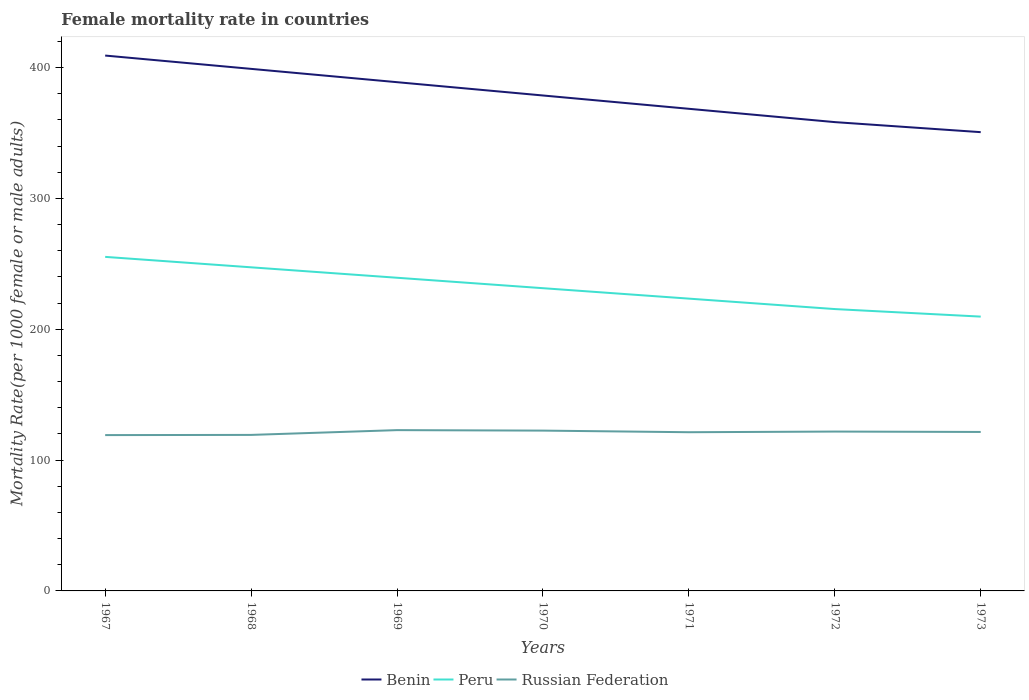How many different coloured lines are there?
Give a very brief answer. 3. Does the line corresponding to Russian Federation intersect with the line corresponding to Benin?
Your answer should be very brief. No. Is the number of lines equal to the number of legend labels?
Offer a terse response. Yes. Across all years, what is the maximum female mortality rate in Peru?
Provide a short and direct response. 209.66. In which year was the female mortality rate in Russian Federation maximum?
Your answer should be compact. 1967. What is the total female mortality rate in Peru in the graph?
Give a very brief answer. 21.72. What is the difference between the highest and the second highest female mortality rate in Benin?
Your response must be concise. 58.55. Is the female mortality rate in Peru strictly greater than the female mortality rate in Russian Federation over the years?
Keep it short and to the point. No. How many lines are there?
Provide a succinct answer. 3. What is the difference between two consecutive major ticks on the Y-axis?
Give a very brief answer. 100. Are the values on the major ticks of Y-axis written in scientific E-notation?
Keep it short and to the point. No. Does the graph contain grids?
Give a very brief answer. No. Where does the legend appear in the graph?
Offer a very short reply. Bottom center. How are the legend labels stacked?
Offer a very short reply. Horizontal. What is the title of the graph?
Offer a terse response. Female mortality rate in countries. Does "Guam" appear as one of the legend labels in the graph?
Your answer should be compact. No. What is the label or title of the X-axis?
Provide a succinct answer. Years. What is the label or title of the Y-axis?
Offer a terse response. Mortality Rate(per 1000 female or male adults). What is the Mortality Rate(per 1000 female or male adults) in Benin in 1967?
Your answer should be compact. 409.19. What is the Mortality Rate(per 1000 female or male adults) of Peru in 1967?
Keep it short and to the point. 255.31. What is the Mortality Rate(per 1000 female or male adults) in Russian Federation in 1967?
Make the answer very short. 119.1. What is the Mortality Rate(per 1000 female or male adults) of Benin in 1968?
Provide a succinct answer. 399.01. What is the Mortality Rate(per 1000 female or male adults) of Peru in 1968?
Provide a succinct answer. 247.34. What is the Mortality Rate(per 1000 female or male adults) of Russian Federation in 1968?
Ensure brevity in your answer.  119.24. What is the Mortality Rate(per 1000 female or male adults) in Benin in 1969?
Your answer should be compact. 388.84. What is the Mortality Rate(per 1000 female or male adults) of Peru in 1969?
Ensure brevity in your answer.  239.36. What is the Mortality Rate(per 1000 female or male adults) of Russian Federation in 1969?
Your answer should be very brief. 122.9. What is the Mortality Rate(per 1000 female or male adults) in Benin in 1970?
Make the answer very short. 378.66. What is the Mortality Rate(per 1000 female or male adults) in Peru in 1970?
Provide a short and direct response. 231.38. What is the Mortality Rate(per 1000 female or male adults) in Russian Federation in 1970?
Your answer should be very brief. 122.53. What is the Mortality Rate(per 1000 female or male adults) in Benin in 1971?
Your response must be concise. 368.49. What is the Mortality Rate(per 1000 female or male adults) in Peru in 1971?
Offer a very short reply. 223.4. What is the Mortality Rate(per 1000 female or male adults) in Russian Federation in 1971?
Provide a succinct answer. 121.3. What is the Mortality Rate(per 1000 female or male adults) of Benin in 1972?
Ensure brevity in your answer.  358.31. What is the Mortality Rate(per 1000 female or male adults) in Peru in 1972?
Provide a succinct answer. 215.43. What is the Mortality Rate(per 1000 female or male adults) in Russian Federation in 1972?
Your answer should be very brief. 121.8. What is the Mortality Rate(per 1000 female or male adults) in Benin in 1973?
Give a very brief answer. 350.64. What is the Mortality Rate(per 1000 female or male adults) of Peru in 1973?
Give a very brief answer. 209.66. What is the Mortality Rate(per 1000 female or male adults) in Russian Federation in 1973?
Ensure brevity in your answer.  121.5. Across all years, what is the maximum Mortality Rate(per 1000 female or male adults) in Benin?
Your answer should be compact. 409.19. Across all years, what is the maximum Mortality Rate(per 1000 female or male adults) in Peru?
Provide a short and direct response. 255.31. Across all years, what is the maximum Mortality Rate(per 1000 female or male adults) in Russian Federation?
Ensure brevity in your answer.  122.9. Across all years, what is the minimum Mortality Rate(per 1000 female or male adults) of Benin?
Keep it short and to the point. 350.64. Across all years, what is the minimum Mortality Rate(per 1000 female or male adults) of Peru?
Give a very brief answer. 209.66. Across all years, what is the minimum Mortality Rate(per 1000 female or male adults) of Russian Federation?
Give a very brief answer. 119.1. What is the total Mortality Rate(per 1000 female or male adults) of Benin in the graph?
Offer a terse response. 2653.14. What is the total Mortality Rate(per 1000 female or male adults) of Peru in the graph?
Give a very brief answer. 1621.88. What is the total Mortality Rate(per 1000 female or male adults) of Russian Federation in the graph?
Give a very brief answer. 848.36. What is the difference between the Mortality Rate(per 1000 female or male adults) of Benin in 1967 and that in 1968?
Give a very brief answer. 10.17. What is the difference between the Mortality Rate(per 1000 female or male adults) in Peru in 1967 and that in 1968?
Your answer should be compact. 7.98. What is the difference between the Mortality Rate(per 1000 female or male adults) in Russian Federation in 1967 and that in 1968?
Give a very brief answer. -0.15. What is the difference between the Mortality Rate(per 1000 female or male adults) in Benin in 1967 and that in 1969?
Provide a short and direct response. 20.35. What is the difference between the Mortality Rate(per 1000 female or male adults) of Peru in 1967 and that in 1969?
Give a very brief answer. 15.96. What is the difference between the Mortality Rate(per 1000 female or male adults) of Russian Federation in 1967 and that in 1969?
Provide a short and direct response. -3.81. What is the difference between the Mortality Rate(per 1000 female or male adults) of Benin in 1967 and that in 1970?
Your answer should be very brief. 30.52. What is the difference between the Mortality Rate(per 1000 female or male adults) in Peru in 1967 and that in 1970?
Keep it short and to the point. 23.93. What is the difference between the Mortality Rate(per 1000 female or male adults) of Russian Federation in 1967 and that in 1970?
Your answer should be compact. -3.43. What is the difference between the Mortality Rate(per 1000 female or male adults) in Benin in 1967 and that in 1971?
Provide a short and direct response. 40.7. What is the difference between the Mortality Rate(per 1000 female or male adults) of Peru in 1967 and that in 1971?
Your answer should be compact. 31.91. What is the difference between the Mortality Rate(per 1000 female or male adults) of Russian Federation in 1967 and that in 1971?
Give a very brief answer. -2.2. What is the difference between the Mortality Rate(per 1000 female or male adults) of Benin in 1967 and that in 1972?
Provide a short and direct response. 50.87. What is the difference between the Mortality Rate(per 1000 female or male adults) in Peru in 1967 and that in 1972?
Offer a terse response. 39.89. What is the difference between the Mortality Rate(per 1000 female or male adults) in Russian Federation in 1967 and that in 1972?
Your response must be concise. -2.7. What is the difference between the Mortality Rate(per 1000 female or male adults) of Benin in 1967 and that in 1973?
Make the answer very short. 58.55. What is the difference between the Mortality Rate(per 1000 female or male adults) of Peru in 1967 and that in 1973?
Make the answer very short. 45.66. What is the difference between the Mortality Rate(per 1000 female or male adults) of Russian Federation in 1967 and that in 1973?
Ensure brevity in your answer.  -2.4. What is the difference between the Mortality Rate(per 1000 female or male adults) in Benin in 1968 and that in 1969?
Your answer should be very brief. 10.18. What is the difference between the Mortality Rate(per 1000 female or male adults) in Peru in 1968 and that in 1969?
Make the answer very short. 7.98. What is the difference between the Mortality Rate(per 1000 female or male adults) in Russian Federation in 1968 and that in 1969?
Offer a very short reply. -3.66. What is the difference between the Mortality Rate(per 1000 female or male adults) in Benin in 1968 and that in 1970?
Your response must be concise. 20.35. What is the difference between the Mortality Rate(per 1000 female or male adults) in Peru in 1968 and that in 1970?
Give a very brief answer. 15.96. What is the difference between the Mortality Rate(per 1000 female or male adults) in Russian Federation in 1968 and that in 1970?
Give a very brief answer. -3.29. What is the difference between the Mortality Rate(per 1000 female or male adults) of Benin in 1968 and that in 1971?
Offer a terse response. 30.52. What is the difference between the Mortality Rate(per 1000 female or male adults) of Peru in 1968 and that in 1971?
Offer a terse response. 23.93. What is the difference between the Mortality Rate(per 1000 female or male adults) of Russian Federation in 1968 and that in 1971?
Your answer should be compact. -2.06. What is the difference between the Mortality Rate(per 1000 female or male adults) in Benin in 1968 and that in 1972?
Provide a succinct answer. 40.7. What is the difference between the Mortality Rate(per 1000 female or male adults) in Peru in 1968 and that in 1972?
Offer a terse response. 31.91. What is the difference between the Mortality Rate(per 1000 female or male adults) in Russian Federation in 1968 and that in 1972?
Your answer should be compact. -2.55. What is the difference between the Mortality Rate(per 1000 female or male adults) of Benin in 1968 and that in 1973?
Make the answer very short. 48.38. What is the difference between the Mortality Rate(per 1000 female or male adults) of Peru in 1968 and that in 1973?
Make the answer very short. 37.68. What is the difference between the Mortality Rate(per 1000 female or male adults) of Russian Federation in 1968 and that in 1973?
Your answer should be very brief. -2.25. What is the difference between the Mortality Rate(per 1000 female or male adults) in Benin in 1969 and that in 1970?
Your answer should be very brief. 10.17. What is the difference between the Mortality Rate(per 1000 female or male adults) in Peru in 1969 and that in 1970?
Your answer should be very brief. 7.98. What is the difference between the Mortality Rate(per 1000 female or male adults) in Russian Federation in 1969 and that in 1970?
Your response must be concise. 0.37. What is the difference between the Mortality Rate(per 1000 female or male adults) in Benin in 1969 and that in 1971?
Your response must be concise. 20.35. What is the difference between the Mortality Rate(per 1000 female or male adults) of Peru in 1969 and that in 1971?
Your answer should be compact. 15.96. What is the difference between the Mortality Rate(per 1000 female or male adults) of Russian Federation in 1969 and that in 1971?
Your answer should be very brief. 1.6. What is the difference between the Mortality Rate(per 1000 female or male adults) of Benin in 1969 and that in 1972?
Your response must be concise. 30.52. What is the difference between the Mortality Rate(per 1000 female or male adults) in Peru in 1969 and that in 1972?
Ensure brevity in your answer.  23.93. What is the difference between the Mortality Rate(per 1000 female or male adults) in Russian Federation in 1969 and that in 1972?
Give a very brief answer. 1.1. What is the difference between the Mortality Rate(per 1000 female or male adults) in Benin in 1969 and that in 1973?
Ensure brevity in your answer.  38.2. What is the difference between the Mortality Rate(per 1000 female or male adults) in Peru in 1969 and that in 1973?
Make the answer very short. 29.7. What is the difference between the Mortality Rate(per 1000 female or male adults) of Russian Federation in 1969 and that in 1973?
Provide a succinct answer. 1.41. What is the difference between the Mortality Rate(per 1000 female or male adults) in Benin in 1970 and that in 1971?
Provide a succinct answer. 10.17. What is the difference between the Mortality Rate(per 1000 female or male adults) of Peru in 1970 and that in 1971?
Your response must be concise. 7.98. What is the difference between the Mortality Rate(per 1000 female or male adults) in Russian Federation in 1970 and that in 1971?
Provide a short and direct response. 1.23. What is the difference between the Mortality Rate(per 1000 female or male adults) of Benin in 1970 and that in 1972?
Offer a terse response. 20.35. What is the difference between the Mortality Rate(per 1000 female or male adults) in Peru in 1970 and that in 1972?
Ensure brevity in your answer.  15.96. What is the difference between the Mortality Rate(per 1000 female or male adults) of Russian Federation in 1970 and that in 1972?
Your response must be concise. 0.73. What is the difference between the Mortality Rate(per 1000 female or male adults) in Benin in 1970 and that in 1973?
Provide a succinct answer. 28.03. What is the difference between the Mortality Rate(per 1000 female or male adults) in Peru in 1970 and that in 1973?
Make the answer very short. 21.72. What is the difference between the Mortality Rate(per 1000 female or male adults) in Russian Federation in 1970 and that in 1973?
Provide a short and direct response. 1.03. What is the difference between the Mortality Rate(per 1000 female or male adults) of Benin in 1971 and that in 1972?
Offer a very short reply. 10.18. What is the difference between the Mortality Rate(per 1000 female or male adults) of Peru in 1971 and that in 1972?
Your answer should be compact. 7.98. What is the difference between the Mortality Rate(per 1000 female or male adults) of Russian Federation in 1971 and that in 1972?
Make the answer very short. -0.5. What is the difference between the Mortality Rate(per 1000 female or male adults) in Benin in 1971 and that in 1973?
Offer a very short reply. 17.85. What is the difference between the Mortality Rate(per 1000 female or male adults) in Peru in 1971 and that in 1973?
Offer a terse response. 13.74. What is the difference between the Mortality Rate(per 1000 female or male adults) in Russian Federation in 1971 and that in 1973?
Offer a terse response. -0.19. What is the difference between the Mortality Rate(per 1000 female or male adults) of Benin in 1972 and that in 1973?
Give a very brief answer. 7.68. What is the difference between the Mortality Rate(per 1000 female or male adults) in Peru in 1972 and that in 1973?
Offer a terse response. 5.77. What is the difference between the Mortality Rate(per 1000 female or male adults) of Russian Federation in 1972 and that in 1973?
Your answer should be very brief. 0.3. What is the difference between the Mortality Rate(per 1000 female or male adults) of Benin in 1967 and the Mortality Rate(per 1000 female or male adults) of Peru in 1968?
Ensure brevity in your answer.  161.85. What is the difference between the Mortality Rate(per 1000 female or male adults) of Benin in 1967 and the Mortality Rate(per 1000 female or male adults) of Russian Federation in 1968?
Ensure brevity in your answer.  289.94. What is the difference between the Mortality Rate(per 1000 female or male adults) in Peru in 1967 and the Mortality Rate(per 1000 female or male adults) in Russian Federation in 1968?
Ensure brevity in your answer.  136.07. What is the difference between the Mortality Rate(per 1000 female or male adults) of Benin in 1967 and the Mortality Rate(per 1000 female or male adults) of Peru in 1969?
Offer a terse response. 169.83. What is the difference between the Mortality Rate(per 1000 female or male adults) of Benin in 1967 and the Mortality Rate(per 1000 female or male adults) of Russian Federation in 1969?
Your answer should be very brief. 286.29. What is the difference between the Mortality Rate(per 1000 female or male adults) of Peru in 1967 and the Mortality Rate(per 1000 female or male adults) of Russian Federation in 1969?
Your answer should be compact. 132.41. What is the difference between the Mortality Rate(per 1000 female or male adults) of Benin in 1967 and the Mortality Rate(per 1000 female or male adults) of Peru in 1970?
Your answer should be very brief. 177.81. What is the difference between the Mortality Rate(per 1000 female or male adults) of Benin in 1967 and the Mortality Rate(per 1000 female or male adults) of Russian Federation in 1970?
Provide a short and direct response. 286.66. What is the difference between the Mortality Rate(per 1000 female or male adults) of Peru in 1967 and the Mortality Rate(per 1000 female or male adults) of Russian Federation in 1970?
Your response must be concise. 132.78. What is the difference between the Mortality Rate(per 1000 female or male adults) of Benin in 1967 and the Mortality Rate(per 1000 female or male adults) of Peru in 1971?
Offer a very short reply. 185.78. What is the difference between the Mortality Rate(per 1000 female or male adults) of Benin in 1967 and the Mortality Rate(per 1000 female or male adults) of Russian Federation in 1971?
Your response must be concise. 287.89. What is the difference between the Mortality Rate(per 1000 female or male adults) of Peru in 1967 and the Mortality Rate(per 1000 female or male adults) of Russian Federation in 1971?
Your response must be concise. 134.01. What is the difference between the Mortality Rate(per 1000 female or male adults) in Benin in 1967 and the Mortality Rate(per 1000 female or male adults) in Peru in 1972?
Make the answer very short. 193.76. What is the difference between the Mortality Rate(per 1000 female or male adults) of Benin in 1967 and the Mortality Rate(per 1000 female or male adults) of Russian Federation in 1972?
Your answer should be very brief. 287.39. What is the difference between the Mortality Rate(per 1000 female or male adults) of Peru in 1967 and the Mortality Rate(per 1000 female or male adults) of Russian Federation in 1972?
Offer a terse response. 133.52. What is the difference between the Mortality Rate(per 1000 female or male adults) of Benin in 1967 and the Mortality Rate(per 1000 female or male adults) of Peru in 1973?
Ensure brevity in your answer.  199.53. What is the difference between the Mortality Rate(per 1000 female or male adults) in Benin in 1967 and the Mortality Rate(per 1000 female or male adults) in Russian Federation in 1973?
Your response must be concise. 287.69. What is the difference between the Mortality Rate(per 1000 female or male adults) in Peru in 1967 and the Mortality Rate(per 1000 female or male adults) in Russian Federation in 1973?
Offer a terse response. 133.82. What is the difference between the Mortality Rate(per 1000 female or male adults) of Benin in 1968 and the Mortality Rate(per 1000 female or male adults) of Peru in 1969?
Provide a short and direct response. 159.65. What is the difference between the Mortality Rate(per 1000 female or male adults) in Benin in 1968 and the Mortality Rate(per 1000 female or male adults) in Russian Federation in 1969?
Provide a succinct answer. 276.11. What is the difference between the Mortality Rate(per 1000 female or male adults) in Peru in 1968 and the Mortality Rate(per 1000 female or male adults) in Russian Federation in 1969?
Keep it short and to the point. 124.44. What is the difference between the Mortality Rate(per 1000 female or male adults) in Benin in 1968 and the Mortality Rate(per 1000 female or male adults) in Peru in 1970?
Ensure brevity in your answer.  167.63. What is the difference between the Mortality Rate(per 1000 female or male adults) of Benin in 1968 and the Mortality Rate(per 1000 female or male adults) of Russian Federation in 1970?
Provide a short and direct response. 276.48. What is the difference between the Mortality Rate(per 1000 female or male adults) in Peru in 1968 and the Mortality Rate(per 1000 female or male adults) in Russian Federation in 1970?
Give a very brief answer. 124.81. What is the difference between the Mortality Rate(per 1000 female or male adults) in Benin in 1968 and the Mortality Rate(per 1000 female or male adults) in Peru in 1971?
Your response must be concise. 175.61. What is the difference between the Mortality Rate(per 1000 female or male adults) of Benin in 1968 and the Mortality Rate(per 1000 female or male adults) of Russian Federation in 1971?
Offer a very short reply. 277.71. What is the difference between the Mortality Rate(per 1000 female or male adults) in Peru in 1968 and the Mortality Rate(per 1000 female or male adults) in Russian Federation in 1971?
Provide a succinct answer. 126.04. What is the difference between the Mortality Rate(per 1000 female or male adults) of Benin in 1968 and the Mortality Rate(per 1000 female or male adults) of Peru in 1972?
Provide a short and direct response. 183.59. What is the difference between the Mortality Rate(per 1000 female or male adults) of Benin in 1968 and the Mortality Rate(per 1000 female or male adults) of Russian Federation in 1972?
Provide a succinct answer. 277.22. What is the difference between the Mortality Rate(per 1000 female or male adults) in Peru in 1968 and the Mortality Rate(per 1000 female or male adults) in Russian Federation in 1972?
Give a very brief answer. 125.54. What is the difference between the Mortality Rate(per 1000 female or male adults) of Benin in 1968 and the Mortality Rate(per 1000 female or male adults) of Peru in 1973?
Your answer should be compact. 189.35. What is the difference between the Mortality Rate(per 1000 female or male adults) in Benin in 1968 and the Mortality Rate(per 1000 female or male adults) in Russian Federation in 1973?
Ensure brevity in your answer.  277.52. What is the difference between the Mortality Rate(per 1000 female or male adults) of Peru in 1968 and the Mortality Rate(per 1000 female or male adults) of Russian Federation in 1973?
Provide a succinct answer. 125.84. What is the difference between the Mortality Rate(per 1000 female or male adults) in Benin in 1969 and the Mortality Rate(per 1000 female or male adults) in Peru in 1970?
Offer a terse response. 157.46. What is the difference between the Mortality Rate(per 1000 female or male adults) in Benin in 1969 and the Mortality Rate(per 1000 female or male adults) in Russian Federation in 1970?
Provide a short and direct response. 266.31. What is the difference between the Mortality Rate(per 1000 female or male adults) in Peru in 1969 and the Mortality Rate(per 1000 female or male adults) in Russian Federation in 1970?
Provide a succinct answer. 116.83. What is the difference between the Mortality Rate(per 1000 female or male adults) of Benin in 1969 and the Mortality Rate(per 1000 female or male adults) of Peru in 1971?
Your answer should be very brief. 165.44. What is the difference between the Mortality Rate(per 1000 female or male adults) in Benin in 1969 and the Mortality Rate(per 1000 female or male adults) in Russian Federation in 1971?
Offer a very short reply. 267.54. What is the difference between the Mortality Rate(per 1000 female or male adults) in Peru in 1969 and the Mortality Rate(per 1000 female or male adults) in Russian Federation in 1971?
Your answer should be compact. 118.06. What is the difference between the Mortality Rate(per 1000 female or male adults) of Benin in 1969 and the Mortality Rate(per 1000 female or male adults) of Peru in 1972?
Give a very brief answer. 173.41. What is the difference between the Mortality Rate(per 1000 female or male adults) in Benin in 1969 and the Mortality Rate(per 1000 female or male adults) in Russian Federation in 1972?
Your answer should be compact. 267.04. What is the difference between the Mortality Rate(per 1000 female or male adults) in Peru in 1969 and the Mortality Rate(per 1000 female or male adults) in Russian Federation in 1972?
Offer a very short reply. 117.56. What is the difference between the Mortality Rate(per 1000 female or male adults) in Benin in 1969 and the Mortality Rate(per 1000 female or male adults) in Peru in 1973?
Make the answer very short. 179.18. What is the difference between the Mortality Rate(per 1000 female or male adults) in Benin in 1969 and the Mortality Rate(per 1000 female or male adults) in Russian Federation in 1973?
Offer a terse response. 267.34. What is the difference between the Mortality Rate(per 1000 female or male adults) of Peru in 1969 and the Mortality Rate(per 1000 female or male adults) of Russian Federation in 1973?
Your answer should be compact. 117.86. What is the difference between the Mortality Rate(per 1000 female or male adults) of Benin in 1970 and the Mortality Rate(per 1000 female or male adults) of Peru in 1971?
Offer a very short reply. 155.26. What is the difference between the Mortality Rate(per 1000 female or male adults) in Benin in 1970 and the Mortality Rate(per 1000 female or male adults) in Russian Federation in 1971?
Offer a terse response. 257.36. What is the difference between the Mortality Rate(per 1000 female or male adults) of Peru in 1970 and the Mortality Rate(per 1000 female or male adults) of Russian Federation in 1971?
Give a very brief answer. 110.08. What is the difference between the Mortality Rate(per 1000 female or male adults) of Benin in 1970 and the Mortality Rate(per 1000 female or male adults) of Peru in 1972?
Give a very brief answer. 163.24. What is the difference between the Mortality Rate(per 1000 female or male adults) in Benin in 1970 and the Mortality Rate(per 1000 female or male adults) in Russian Federation in 1972?
Your answer should be compact. 256.87. What is the difference between the Mortality Rate(per 1000 female or male adults) of Peru in 1970 and the Mortality Rate(per 1000 female or male adults) of Russian Federation in 1972?
Offer a terse response. 109.58. What is the difference between the Mortality Rate(per 1000 female or male adults) of Benin in 1970 and the Mortality Rate(per 1000 female or male adults) of Peru in 1973?
Keep it short and to the point. 169.01. What is the difference between the Mortality Rate(per 1000 female or male adults) in Benin in 1970 and the Mortality Rate(per 1000 female or male adults) in Russian Federation in 1973?
Keep it short and to the point. 257.17. What is the difference between the Mortality Rate(per 1000 female or male adults) in Peru in 1970 and the Mortality Rate(per 1000 female or male adults) in Russian Federation in 1973?
Your answer should be compact. 109.89. What is the difference between the Mortality Rate(per 1000 female or male adults) of Benin in 1971 and the Mortality Rate(per 1000 female or male adults) of Peru in 1972?
Make the answer very short. 153.06. What is the difference between the Mortality Rate(per 1000 female or male adults) in Benin in 1971 and the Mortality Rate(per 1000 female or male adults) in Russian Federation in 1972?
Your response must be concise. 246.69. What is the difference between the Mortality Rate(per 1000 female or male adults) in Peru in 1971 and the Mortality Rate(per 1000 female or male adults) in Russian Federation in 1972?
Offer a very short reply. 101.61. What is the difference between the Mortality Rate(per 1000 female or male adults) of Benin in 1971 and the Mortality Rate(per 1000 female or male adults) of Peru in 1973?
Make the answer very short. 158.83. What is the difference between the Mortality Rate(per 1000 female or male adults) of Benin in 1971 and the Mortality Rate(per 1000 female or male adults) of Russian Federation in 1973?
Keep it short and to the point. 247. What is the difference between the Mortality Rate(per 1000 female or male adults) in Peru in 1971 and the Mortality Rate(per 1000 female or male adults) in Russian Federation in 1973?
Offer a terse response. 101.91. What is the difference between the Mortality Rate(per 1000 female or male adults) of Benin in 1972 and the Mortality Rate(per 1000 female or male adults) of Peru in 1973?
Offer a very short reply. 148.66. What is the difference between the Mortality Rate(per 1000 female or male adults) in Benin in 1972 and the Mortality Rate(per 1000 female or male adults) in Russian Federation in 1973?
Offer a terse response. 236.82. What is the difference between the Mortality Rate(per 1000 female or male adults) of Peru in 1972 and the Mortality Rate(per 1000 female or male adults) of Russian Federation in 1973?
Provide a short and direct response. 93.93. What is the average Mortality Rate(per 1000 female or male adults) in Benin per year?
Offer a terse response. 379.02. What is the average Mortality Rate(per 1000 female or male adults) in Peru per year?
Your answer should be very brief. 231.7. What is the average Mortality Rate(per 1000 female or male adults) in Russian Federation per year?
Provide a succinct answer. 121.19. In the year 1967, what is the difference between the Mortality Rate(per 1000 female or male adults) of Benin and Mortality Rate(per 1000 female or male adults) of Peru?
Provide a short and direct response. 153.87. In the year 1967, what is the difference between the Mortality Rate(per 1000 female or male adults) in Benin and Mortality Rate(per 1000 female or male adults) in Russian Federation?
Provide a short and direct response. 290.09. In the year 1967, what is the difference between the Mortality Rate(per 1000 female or male adults) of Peru and Mortality Rate(per 1000 female or male adults) of Russian Federation?
Ensure brevity in your answer.  136.22. In the year 1968, what is the difference between the Mortality Rate(per 1000 female or male adults) in Benin and Mortality Rate(per 1000 female or male adults) in Peru?
Make the answer very short. 151.68. In the year 1968, what is the difference between the Mortality Rate(per 1000 female or male adults) of Benin and Mortality Rate(per 1000 female or male adults) of Russian Federation?
Give a very brief answer. 279.77. In the year 1968, what is the difference between the Mortality Rate(per 1000 female or male adults) of Peru and Mortality Rate(per 1000 female or male adults) of Russian Federation?
Make the answer very short. 128.09. In the year 1969, what is the difference between the Mortality Rate(per 1000 female or male adults) of Benin and Mortality Rate(per 1000 female or male adults) of Peru?
Provide a succinct answer. 149.48. In the year 1969, what is the difference between the Mortality Rate(per 1000 female or male adults) of Benin and Mortality Rate(per 1000 female or male adults) of Russian Federation?
Offer a very short reply. 265.94. In the year 1969, what is the difference between the Mortality Rate(per 1000 female or male adults) in Peru and Mortality Rate(per 1000 female or male adults) in Russian Federation?
Your response must be concise. 116.46. In the year 1970, what is the difference between the Mortality Rate(per 1000 female or male adults) in Benin and Mortality Rate(per 1000 female or male adults) in Peru?
Offer a terse response. 147.28. In the year 1970, what is the difference between the Mortality Rate(per 1000 female or male adults) in Benin and Mortality Rate(per 1000 female or male adults) in Russian Federation?
Offer a very short reply. 256.13. In the year 1970, what is the difference between the Mortality Rate(per 1000 female or male adults) in Peru and Mortality Rate(per 1000 female or male adults) in Russian Federation?
Give a very brief answer. 108.85. In the year 1971, what is the difference between the Mortality Rate(per 1000 female or male adults) in Benin and Mortality Rate(per 1000 female or male adults) in Peru?
Offer a very short reply. 145.09. In the year 1971, what is the difference between the Mortality Rate(per 1000 female or male adults) in Benin and Mortality Rate(per 1000 female or male adults) in Russian Federation?
Offer a very short reply. 247.19. In the year 1971, what is the difference between the Mortality Rate(per 1000 female or male adults) of Peru and Mortality Rate(per 1000 female or male adults) of Russian Federation?
Your answer should be compact. 102.1. In the year 1972, what is the difference between the Mortality Rate(per 1000 female or male adults) in Benin and Mortality Rate(per 1000 female or male adults) in Peru?
Offer a very short reply. 142.89. In the year 1972, what is the difference between the Mortality Rate(per 1000 female or male adults) in Benin and Mortality Rate(per 1000 female or male adults) in Russian Federation?
Provide a short and direct response. 236.52. In the year 1972, what is the difference between the Mortality Rate(per 1000 female or male adults) of Peru and Mortality Rate(per 1000 female or male adults) of Russian Federation?
Ensure brevity in your answer.  93.63. In the year 1973, what is the difference between the Mortality Rate(per 1000 female or male adults) of Benin and Mortality Rate(per 1000 female or male adults) of Peru?
Offer a very short reply. 140.98. In the year 1973, what is the difference between the Mortality Rate(per 1000 female or male adults) in Benin and Mortality Rate(per 1000 female or male adults) in Russian Federation?
Provide a short and direct response. 229.14. In the year 1973, what is the difference between the Mortality Rate(per 1000 female or male adults) in Peru and Mortality Rate(per 1000 female or male adults) in Russian Federation?
Give a very brief answer. 88.16. What is the ratio of the Mortality Rate(per 1000 female or male adults) in Benin in 1967 to that in 1968?
Your answer should be very brief. 1.03. What is the ratio of the Mortality Rate(per 1000 female or male adults) in Peru in 1967 to that in 1968?
Ensure brevity in your answer.  1.03. What is the ratio of the Mortality Rate(per 1000 female or male adults) of Benin in 1967 to that in 1969?
Provide a short and direct response. 1.05. What is the ratio of the Mortality Rate(per 1000 female or male adults) of Peru in 1967 to that in 1969?
Give a very brief answer. 1.07. What is the ratio of the Mortality Rate(per 1000 female or male adults) in Benin in 1967 to that in 1970?
Your answer should be very brief. 1.08. What is the ratio of the Mortality Rate(per 1000 female or male adults) in Peru in 1967 to that in 1970?
Your response must be concise. 1.1. What is the ratio of the Mortality Rate(per 1000 female or male adults) in Benin in 1967 to that in 1971?
Provide a succinct answer. 1.11. What is the ratio of the Mortality Rate(per 1000 female or male adults) of Peru in 1967 to that in 1971?
Your answer should be compact. 1.14. What is the ratio of the Mortality Rate(per 1000 female or male adults) of Russian Federation in 1967 to that in 1971?
Provide a short and direct response. 0.98. What is the ratio of the Mortality Rate(per 1000 female or male adults) of Benin in 1967 to that in 1972?
Your answer should be compact. 1.14. What is the ratio of the Mortality Rate(per 1000 female or male adults) of Peru in 1967 to that in 1972?
Give a very brief answer. 1.19. What is the ratio of the Mortality Rate(per 1000 female or male adults) in Russian Federation in 1967 to that in 1972?
Keep it short and to the point. 0.98. What is the ratio of the Mortality Rate(per 1000 female or male adults) of Benin in 1967 to that in 1973?
Provide a succinct answer. 1.17. What is the ratio of the Mortality Rate(per 1000 female or male adults) in Peru in 1967 to that in 1973?
Ensure brevity in your answer.  1.22. What is the ratio of the Mortality Rate(per 1000 female or male adults) in Russian Federation in 1967 to that in 1973?
Provide a short and direct response. 0.98. What is the ratio of the Mortality Rate(per 1000 female or male adults) in Benin in 1968 to that in 1969?
Give a very brief answer. 1.03. What is the ratio of the Mortality Rate(per 1000 female or male adults) in Peru in 1968 to that in 1969?
Offer a very short reply. 1.03. What is the ratio of the Mortality Rate(per 1000 female or male adults) in Russian Federation in 1968 to that in 1969?
Ensure brevity in your answer.  0.97. What is the ratio of the Mortality Rate(per 1000 female or male adults) of Benin in 1968 to that in 1970?
Ensure brevity in your answer.  1.05. What is the ratio of the Mortality Rate(per 1000 female or male adults) in Peru in 1968 to that in 1970?
Provide a short and direct response. 1.07. What is the ratio of the Mortality Rate(per 1000 female or male adults) of Russian Federation in 1968 to that in 1970?
Make the answer very short. 0.97. What is the ratio of the Mortality Rate(per 1000 female or male adults) in Benin in 1968 to that in 1971?
Offer a very short reply. 1.08. What is the ratio of the Mortality Rate(per 1000 female or male adults) of Peru in 1968 to that in 1971?
Ensure brevity in your answer.  1.11. What is the ratio of the Mortality Rate(per 1000 female or male adults) in Russian Federation in 1968 to that in 1971?
Make the answer very short. 0.98. What is the ratio of the Mortality Rate(per 1000 female or male adults) in Benin in 1968 to that in 1972?
Make the answer very short. 1.11. What is the ratio of the Mortality Rate(per 1000 female or male adults) in Peru in 1968 to that in 1972?
Your response must be concise. 1.15. What is the ratio of the Mortality Rate(per 1000 female or male adults) of Russian Federation in 1968 to that in 1972?
Your answer should be compact. 0.98. What is the ratio of the Mortality Rate(per 1000 female or male adults) in Benin in 1968 to that in 1973?
Your answer should be very brief. 1.14. What is the ratio of the Mortality Rate(per 1000 female or male adults) in Peru in 1968 to that in 1973?
Your response must be concise. 1.18. What is the ratio of the Mortality Rate(per 1000 female or male adults) in Russian Federation in 1968 to that in 1973?
Offer a terse response. 0.98. What is the ratio of the Mortality Rate(per 1000 female or male adults) in Benin in 1969 to that in 1970?
Provide a succinct answer. 1.03. What is the ratio of the Mortality Rate(per 1000 female or male adults) in Peru in 1969 to that in 1970?
Provide a short and direct response. 1.03. What is the ratio of the Mortality Rate(per 1000 female or male adults) of Benin in 1969 to that in 1971?
Your answer should be very brief. 1.06. What is the ratio of the Mortality Rate(per 1000 female or male adults) in Peru in 1969 to that in 1971?
Give a very brief answer. 1.07. What is the ratio of the Mortality Rate(per 1000 female or male adults) in Russian Federation in 1969 to that in 1971?
Give a very brief answer. 1.01. What is the ratio of the Mortality Rate(per 1000 female or male adults) of Benin in 1969 to that in 1972?
Your answer should be very brief. 1.09. What is the ratio of the Mortality Rate(per 1000 female or male adults) of Russian Federation in 1969 to that in 1972?
Provide a short and direct response. 1.01. What is the ratio of the Mortality Rate(per 1000 female or male adults) of Benin in 1969 to that in 1973?
Offer a terse response. 1.11. What is the ratio of the Mortality Rate(per 1000 female or male adults) of Peru in 1969 to that in 1973?
Make the answer very short. 1.14. What is the ratio of the Mortality Rate(per 1000 female or male adults) in Russian Federation in 1969 to that in 1973?
Your answer should be compact. 1.01. What is the ratio of the Mortality Rate(per 1000 female or male adults) in Benin in 1970 to that in 1971?
Give a very brief answer. 1.03. What is the ratio of the Mortality Rate(per 1000 female or male adults) in Peru in 1970 to that in 1971?
Give a very brief answer. 1.04. What is the ratio of the Mortality Rate(per 1000 female or male adults) in Russian Federation in 1970 to that in 1971?
Keep it short and to the point. 1.01. What is the ratio of the Mortality Rate(per 1000 female or male adults) of Benin in 1970 to that in 1972?
Ensure brevity in your answer.  1.06. What is the ratio of the Mortality Rate(per 1000 female or male adults) in Peru in 1970 to that in 1972?
Keep it short and to the point. 1.07. What is the ratio of the Mortality Rate(per 1000 female or male adults) in Russian Federation in 1970 to that in 1972?
Your answer should be very brief. 1.01. What is the ratio of the Mortality Rate(per 1000 female or male adults) of Benin in 1970 to that in 1973?
Provide a short and direct response. 1.08. What is the ratio of the Mortality Rate(per 1000 female or male adults) of Peru in 1970 to that in 1973?
Offer a terse response. 1.1. What is the ratio of the Mortality Rate(per 1000 female or male adults) in Russian Federation in 1970 to that in 1973?
Give a very brief answer. 1.01. What is the ratio of the Mortality Rate(per 1000 female or male adults) of Benin in 1971 to that in 1972?
Provide a short and direct response. 1.03. What is the ratio of the Mortality Rate(per 1000 female or male adults) of Russian Federation in 1971 to that in 1972?
Give a very brief answer. 1. What is the ratio of the Mortality Rate(per 1000 female or male adults) of Benin in 1971 to that in 1973?
Offer a terse response. 1.05. What is the ratio of the Mortality Rate(per 1000 female or male adults) of Peru in 1971 to that in 1973?
Your response must be concise. 1.07. What is the ratio of the Mortality Rate(per 1000 female or male adults) in Russian Federation in 1971 to that in 1973?
Keep it short and to the point. 1. What is the ratio of the Mortality Rate(per 1000 female or male adults) in Benin in 1972 to that in 1973?
Offer a terse response. 1.02. What is the ratio of the Mortality Rate(per 1000 female or male adults) in Peru in 1972 to that in 1973?
Offer a terse response. 1.03. What is the difference between the highest and the second highest Mortality Rate(per 1000 female or male adults) in Benin?
Provide a succinct answer. 10.17. What is the difference between the highest and the second highest Mortality Rate(per 1000 female or male adults) in Peru?
Your answer should be very brief. 7.98. What is the difference between the highest and the second highest Mortality Rate(per 1000 female or male adults) in Russian Federation?
Provide a succinct answer. 0.37. What is the difference between the highest and the lowest Mortality Rate(per 1000 female or male adults) in Benin?
Offer a terse response. 58.55. What is the difference between the highest and the lowest Mortality Rate(per 1000 female or male adults) in Peru?
Ensure brevity in your answer.  45.66. What is the difference between the highest and the lowest Mortality Rate(per 1000 female or male adults) of Russian Federation?
Make the answer very short. 3.81. 